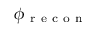Convert formula to latex. <formula><loc_0><loc_0><loc_500><loc_500>\phi _ { r e c o n }</formula> 